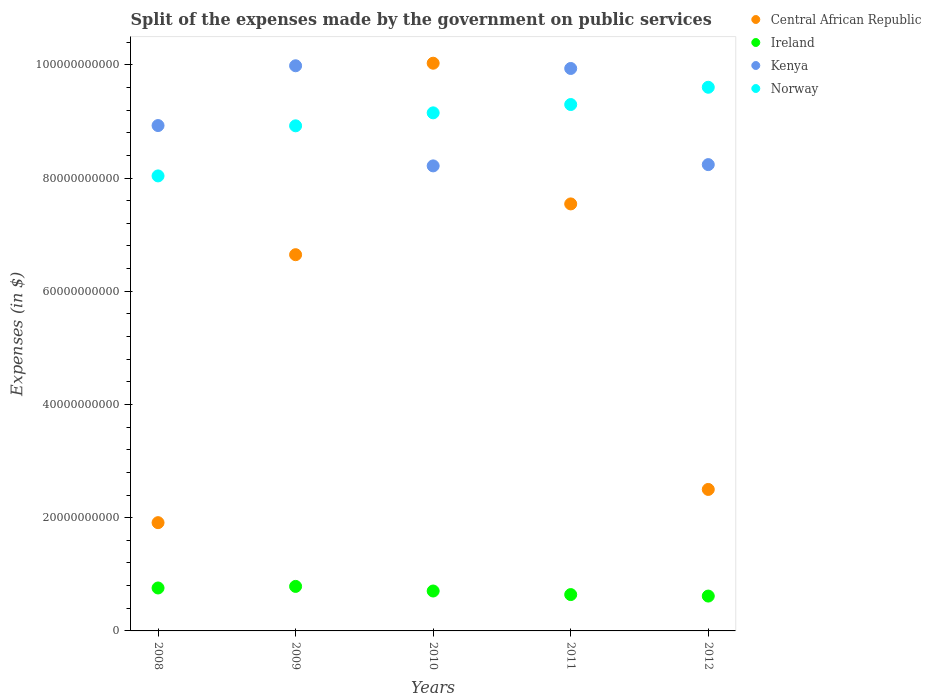How many different coloured dotlines are there?
Give a very brief answer. 4. What is the expenses made by the government on public services in Ireland in 2011?
Make the answer very short. 6.42e+09. Across all years, what is the maximum expenses made by the government on public services in Central African Republic?
Provide a short and direct response. 1.00e+11. Across all years, what is the minimum expenses made by the government on public services in Kenya?
Your response must be concise. 8.22e+1. In which year was the expenses made by the government on public services in Central African Republic maximum?
Provide a short and direct response. 2010. What is the total expenses made by the government on public services in Ireland in the graph?
Offer a terse response. 3.51e+1. What is the difference between the expenses made by the government on public services in Kenya in 2010 and that in 2011?
Provide a succinct answer. -1.72e+1. What is the difference between the expenses made by the government on public services in Norway in 2011 and the expenses made by the government on public services in Ireland in 2009?
Offer a very short reply. 8.51e+1. What is the average expenses made by the government on public services in Kenya per year?
Provide a short and direct response. 9.06e+1. In the year 2009, what is the difference between the expenses made by the government on public services in Ireland and expenses made by the government on public services in Kenya?
Ensure brevity in your answer.  -9.20e+1. What is the ratio of the expenses made by the government on public services in Norway in 2010 to that in 2012?
Offer a terse response. 0.95. Is the difference between the expenses made by the government on public services in Ireland in 2008 and 2011 greater than the difference between the expenses made by the government on public services in Kenya in 2008 and 2011?
Ensure brevity in your answer.  Yes. What is the difference between the highest and the second highest expenses made by the government on public services in Central African Republic?
Your answer should be compact. 2.49e+1. What is the difference between the highest and the lowest expenses made by the government on public services in Ireland?
Provide a short and direct response. 1.71e+09. Is the sum of the expenses made by the government on public services in Central African Republic in 2008 and 2009 greater than the maximum expenses made by the government on public services in Kenya across all years?
Offer a very short reply. No. Is it the case that in every year, the sum of the expenses made by the government on public services in Central African Republic and expenses made by the government on public services in Ireland  is greater than the sum of expenses made by the government on public services in Kenya and expenses made by the government on public services in Norway?
Offer a very short reply. No. Is it the case that in every year, the sum of the expenses made by the government on public services in Central African Republic and expenses made by the government on public services in Norway  is greater than the expenses made by the government on public services in Ireland?
Offer a very short reply. Yes. Is the expenses made by the government on public services in Central African Republic strictly greater than the expenses made by the government on public services in Ireland over the years?
Provide a short and direct response. Yes. Is the expenses made by the government on public services in Central African Republic strictly less than the expenses made by the government on public services in Kenya over the years?
Make the answer very short. No. How many dotlines are there?
Keep it short and to the point. 4. How many years are there in the graph?
Offer a terse response. 5. Are the values on the major ticks of Y-axis written in scientific E-notation?
Provide a short and direct response. No. Where does the legend appear in the graph?
Ensure brevity in your answer.  Top right. How many legend labels are there?
Give a very brief answer. 4. How are the legend labels stacked?
Offer a terse response. Vertical. What is the title of the graph?
Your response must be concise. Split of the expenses made by the government on public services. Does "Poland" appear as one of the legend labels in the graph?
Keep it short and to the point. No. What is the label or title of the Y-axis?
Make the answer very short. Expenses (in $). What is the Expenses (in $) of Central African Republic in 2008?
Offer a very short reply. 1.91e+1. What is the Expenses (in $) in Ireland in 2008?
Your answer should be compact. 7.59e+09. What is the Expenses (in $) of Kenya in 2008?
Provide a succinct answer. 8.93e+1. What is the Expenses (in $) in Norway in 2008?
Your answer should be compact. 8.04e+1. What is the Expenses (in $) of Central African Republic in 2009?
Offer a very short reply. 6.65e+1. What is the Expenses (in $) in Ireland in 2009?
Ensure brevity in your answer.  7.87e+09. What is the Expenses (in $) in Kenya in 2009?
Provide a succinct answer. 9.98e+1. What is the Expenses (in $) of Norway in 2009?
Make the answer very short. 8.92e+1. What is the Expenses (in $) of Central African Republic in 2010?
Your response must be concise. 1.00e+11. What is the Expenses (in $) of Ireland in 2010?
Your response must be concise. 7.05e+09. What is the Expenses (in $) in Kenya in 2010?
Provide a short and direct response. 8.22e+1. What is the Expenses (in $) in Norway in 2010?
Offer a terse response. 9.15e+1. What is the Expenses (in $) in Central African Republic in 2011?
Make the answer very short. 7.54e+1. What is the Expenses (in $) in Ireland in 2011?
Provide a short and direct response. 6.42e+09. What is the Expenses (in $) in Kenya in 2011?
Give a very brief answer. 9.94e+1. What is the Expenses (in $) of Norway in 2011?
Provide a succinct answer. 9.30e+1. What is the Expenses (in $) in Central African Republic in 2012?
Provide a succinct answer. 2.50e+1. What is the Expenses (in $) of Ireland in 2012?
Provide a short and direct response. 6.16e+09. What is the Expenses (in $) of Kenya in 2012?
Offer a very short reply. 8.24e+1. What is the Expenses (in $) in Norway in 2012?
Your response must be concise. 9.60e+1. Across all years, what is the maximum Expenses (in $) of Central African Republic?
Offer a very short reply. 1.00e+11. Across all years, what is the maximum Expenses (in $) of Ireland?
Your response must be concise. 7.87e+09. Across all years, what is the maximum Expenses (in $) in Kenya?
Give a very brief answer. 9.98e+1. Across all years, what is the maximum Expenses (in $) of Norway?
Ensure brevity in your answer.  9.60e+1. Across all years, what is the minimum Expenses (in $) of Central African Republic?
Give a very brief answer. 1.91e+1. Across all years, what is the minimum Expenses (in $) of Ireland?
Your answer should be very brief. 6.16e+09. Across all years, what is the minimum Expenses (in $) of Kenya?
Make the answer very short. 8.22e+1. Across all years, what is the minimum Expenses (in $) of Norway?
Ensure brevity in your answer.  8.04e+1. What is the total Expenses (in $) of Central African Republic in the graph?
Give a very brief answer. 2.86e+11. What is the total Expenses (in $) in Ireland in the graph?
Your response must be concise. 3.51e+1. What is the total Expenses (in $) in Kenya in the graph?
Your response must be concise. 4.53e+11. What is the total Expenses (in $) of Norway in the graph?
Offer a very short reply. 4.50e+11. What is the difference between the Expenses (in $) in Central African Republic in 2008 and that in 2009?
Provide a short and direct response. -4.73e+1. What is the difference between the Expenses (in $) of Ireland in 2008 and that in 2009?
Give a very brief answer. -2.79e+08. What is the difference between the Expenses (in $) of Kenya in 2008 and that in 2009?
Offer a terse response. -1.06e+1. What is the difference between the Expenses (in $) in Norway in 2008 and that in 2009?
Provide a succinct answer. -8.85e+09. What is the difference between the Expenses (in $) of Central African Republic in 2008 and that in 2010?
Provide a succinct answer. -8.12e+1. What is the difference between the Expenses (in $) in Ireland in 2008 and that in 2010?
Give a very brief answer. 5.35e+08. What is the difference between the Expenses (in $) in Kenya in 2008 and that in 2010?
Ensure brevity in your answer.  7.13e+09. What is the difference between the Expenses (in $) of Norway in 2008 and that in 2010?
Your answer should be very brief. -1.11e+1. What is the difference between the Expenses (in $) in Central African Republic in 2008 and that in 2011?
Make the answer very short. -5.63e+1. What is the difference between the Expenses (in $) in Ireland in 2008 and that in 2011?
Your response must be concise. 1.17e+09. What is the difference between the Expenses (in $) of Kenya in 2008 and that in 2011?
Your response must be concise. -1.01e+1. What is the difference between the Expenses (in $) of Norway in 2008 and that in 2011?
Give a very brief answer. -1.26e+1. What is the difference between the Expenses (in $) of Central African Republic in 2008 and that in 2012?
Your response must be concise. -5.87e+09. What is the difference between the Expenses (in $) of Ireland in 2008 and that in 2012?
Your answer should be compact. 1.43e+09. What is the difference between the Expenses (in $) of Kenya in 2008 and that in 2012?
Offer a very short reply. 6.90e+09. What is the difference between the Expenses (in $) in Norway in 2008 and that in 2012?
Offer a terse response. -1.57e+1. What is the difference between the Expenses (in $) of Central African Republic in 2009 and that in 2010?
Ensure brevity in your answer.  -3.38e+1. What is the difference between the Expenses (in $) of Ireland in 2009 and that in 2010?
Provide a short and direct response. 8.15e+08. What is the difference between the Expenses (in $) in Kenya in 2009 and that in 2010?
Ensure brevity in your answer.  1.77e+1. What is the difference between the Expenses (in $) of Norway in 2009 and that in 2010?
Provide a short and direct response. -2.29e+09. What is the difference between the Expenses (in $) of Central African Republic in 2009 and that in 2011?
Your answer should be very brief. -8.97e+09. What is the difference between the Expenses (in $) of Ireland in 2009 and that in 2011?
Provide a short and direct response. 1.45e+09. What is the difference between the Expenses (in $) of Kenya in 2009 and that in 2011?
Make the answer very short. 4.78e+08. What is the difference between the Expenses (in $) of Norway in 2009 and that in 2011?
Keep it short and to the point. -3.76e+09. What is the difference between the Expenses (in $) of Central African Republic in 2009 and that in 2012?
Your answer should be compact. 4.15e+1. What is the difference between the Expenses (in $) in Ireland in 2009 and that in 2012?
Offer a terse response. 1.71e+09. What is the difference between the Expenses (in $) in Kenya in 2009 and that in 2012?
Ensure brevity in your answer.  1.75e+1. What is the difference between the Expenses (in $) in Norway in 2009 and that in 2012?
Your response must be concise. -6.81e+09. What is the difference between the Expenses (in $) in Central African Republic in 2010 and that in 2011?
Make the answer very short. 2.49e+1. What is the difference between the Expenses (in $) of Ireland in 2010 and that in 2011?
Keep it short and to the point. 6.31e+08. What is the difference between the Expenses (in $) in Kenya in 2010 and that in 2011?
Keep it short and to the point. -1.72e+1. What is the difference between the Expenses (in $) of Norway in 2010 and that in 2011?
Ensure brevity in your answer.  -1.47e+09. What is the difference between the Expenses (in $) of Central African Republic in 2010 and that in 2012?
Provide a short and direct response. 7.53e+1. What is the difference between the Expenses (in $) in Ireland in 2010 and that in 2012?
Make the answer very short. 8.94e+08. What is the difference between the Expenses (in $) of Kenya in 2010 and that in 2012?
Offer a very short reply. -2.26e+08. What is the difference between the Expenses (in $) in Norway in 2010 and that in 2012?
Keep it short and to the point. -4.52e+09. What is the difference between the Expenses (in $) of Central African Republic in 2011 and that in 2012?
Your response must be concise. 5.04e+1. What is the difference between the Expenses (in $) of Ireland in 2011 and that in 2012?
Provide a succinct answer. 2.63e+08. What is the difference between the Expenses (in $) of Kenya in 2011 and that in 2012?
Your response must be concise. 1.70e+1. What is the difference between the Expenses (in $) in Norway in 2011 and that in 2012?
Give a very brief answer. -3.05e+09. What is the difference between the Expenses (in $) of Central African Republic in 2008 and the Expenses (in $) of Ireland in 2009?
Make the answer very short. 1.13e+1. What is the difference between the Expenses (in $) of Central African Republic in 2008 and the Expenses (in $) of Kenya in 2009?
Ensure brevity in your answer.  -8.07e+1. What is the difference between the Expenses (in $) of Central African Republic in 2008 and the Expenses (in $) of Norway in 2009?
Your answer should be very brief. -7.01e+1. What is the difference between the Expenses (in $) of Ireland in 2008 and the Expenses (in $) of Kenya in 2009?
Your answer should be compact. -9.23e+1. What is the difference between the Expenses (in $) in Ireland in 2008 and the Expenses (in $) in Norway in 2009?
Your answer should be very brief. -8.16e+1. What is the difference between the Expenses (in $) of Kenya in 2008 and the Expenses (in $) of Norway in 2009?
Offer a very short reply. 4.59e+07. What is the difference between the Expenses (in $) in Central African Republic in 2008 and the Expenses (in $) in Ireland in 2010?
Your answer should be very brief. 1.21e+1. What is the difference between the Expenses (in $) of Central African Republic in 2008 and the Expenses (in $) of Kenya in 2010?
Provide a succinct answer. -6.30e+1. What is the difference between the Expenses (in $) of Central African Republic in 2008 and the Expenses (in $) of Norway in 2010?
Offer a very short reply. -7.24e+1. What is the difference between the Expenses (in $) in Ireland in 2008 and the Expenses (in $) in Kenya in 2010?
Provide a short and direct response. -7.46e+1. What is the difference between the Expenses (in $) in Ireland in 2008 and the Expenses (in $) in Norway in 2010?
Provide a short and direct response. -8.39e+1. What is the difference between the Expenses (in $) of Kenya in 2008 and the Expenses (in $) of Norway in 2010?
Offer a very short reply. -2.24e+09. What is the difference between the Expenses (in $) of Central African Republic in 2008 and the Expenses (in $) of Ireland in 2011?
Make the answer very short. 1.27e+1. What is the difference between the Expenses (in $) in Central African Republic in 2008 and the Expenses (in $) in Kenya in 2011?
Your answer should be very brief. -8.02e+1. What is the difference between the Expenses (in $) of Central African Republic in 2008 and the Expenses (in $) of Norway in 2011?
Offer a terse response. -7.39e+1. What is the difference between the Expenses (in $) in Ireland in 2008 and the Expenses (in $) in Kenya in 2011?
Make the answer very short. -9.18e+1. What is the difference between the Expenses (in $) of Ireland in 2008 and the Expenses (in $) of Norway in 2011?
Ensure brevity in your answer.  -8.54e+1. What is the difference between the Expenses (in $) of Kenya in 2008 and the Expenses (in $) of Norway in 2011?
Give a very brief answer. -3.71e+09. What is the difference between the Expenses (in $) in Central African Republic in 2008 and the Expenses (in $) in Ireland in 2012?
Give a very brief answer. 1.30e+1. What is the difference between the Expenses (in $) in Central African Republic in 2008 and the Expenses (in $) in Kenya in 2012?
Offer a terse response. -6.33e+1. What is the difference between the Expenses (in $) in Central African Republic in 2008 and the Expenses (in $) in Norway in 2012?
Offer a very short reply. -7.69e+1. What is the difference between the Expenses (in $) in Ireland in 2008 and the Expenses (in $) in Kenya in 2012?
Ensure brevity in your answer.  -7.48e+1. What is the difference between the Expenses (in $) in Ireland in 2008 and the Expenses (in $) in Norway in 2012?
Give a very brief answer. -8.85e+1. What is the difference between the Expenses (in $) in Kenya in 2008 and the Expenses (in $) in Norway in 2012?
Provide a short and direct response. -6.76e+09. What is the difference between the Expenses (in $) of Central African Republic in 2009 and the Expenses (in $) of Ireland in 2010?
Offer a very short reply. 5.94e+1. What is the difference between the Expenses (in $) of Central African Republic in 2009 and the Expenses (in $) of Kenya in 2010?
Give a very brief answer. -1.57e+1. What is the difference between the Expenses (in $) of Central African Republic in 2009 and the Expenses (in $) of Norway in 2010?
Keep it short and to the point. -2.51e+1. What is the difference between the Expenses (in $) of Ireland in 2009 and the Expenses (in $) of Kenya in 2010?
Offer a terse response. -7.43e+1. What is the difference between the Expenses (in $) in Ireland in 2009 and the Expenses (in $) in Norway in 2010?
Your answer should be very brief. -8.37e+1. What is the difference between the Expenses (in $) of Kenya in 2009 and the Expenses (in $) of Norway in 2010?
Keep it short and to the point. 8.32e+09. What is the difference between the Expenses (in $) of Central African Republic in 2009 and the Expenses (in $) of Ireland in 2011?
Give a very brief answer. 6.00e+1. What is the difference between the Expenses (in $) of Central African Republic in 2009 and the Expenses (in $) of Kenya in 2011?
Make the answer very short. -3.29e+1. What is the difference between the Expenses (in $) in Central African Republic in 2009 and the Expenses (in $) in Norway in 2011?
Give a very brief answer. -2.65e+1. What is the difference between the Expenses (in $) in Ireland in 2009 and the Expenses (in $) in Kenya in 2011?
Keep it short and to the point. -9.15e+1. What is the difference between the Expenses (in $) of Ireland in 2009 and the Expenses (in $) of Norway in 2011?
Offer a terse response. -8.51e+1. What is the difference between the Expenses (in $) in Kenya in 2009 and the Expenses (in $) in Norway in 2011?
Make the answer very short. 6.85e+09. What is the difference between the Expenses (in $) of Central African Republic in 2009 and the Expenses (in $) of Ireland in 2012?
Your response must be concise. 6.03e+1. What is the difference between the Expenses (in $) in Central African Republic in 2009 and the Expenses (in $) in Kenya in 2012?
Provide a succinct answer. -1.59e+1. What is the difference between the Expenses (in $) in Central African Republic in 2009 and the Expenses (in $) in Norway in 2012?
Keep it short and to the point. -2.96e+1. What is the difference between the Expenses (in $) in Ireland in 2009 and the Expenses (in $) in Kenya in 2012?
Offer a terse response. -7.45e+1. What is the difference between the Expenses (in $) in Ireland in 2009 and the Expenses (in $) in Norway in 2012?
Your answer should be compact. -8.82e+1. What is the difference between the Expenses (in $) in Kenya in 2009 and the Expenses (in $) in Norway in 2012?
Keep it short and to the point. 3.80e+09. What is the difference between the Expenses (in $) in Central African Republic in 2010 and the Expenses (in $) in Ireland in 2011?
Make the answer very short. 9.39e+1. What is the difference between the Expenses (in $) of Central African Republic in 2010 and the Expenses (in $) of Kenya in 2011?
Your answer should be compact. 9.28e+08. What is the difference between the Expenses (in $) of Central African Republic in 2010 and the Expenses (in $) of Norway in 2011?
Ensure brevity in your answer.  7.30e+09. What is the difference between the Expenses (in $) in Ireland in 2010 and the Expenses (in $) in Kenya in 2011?
Provide a succinct answer. -9.23e+1. What is the difference between the Expenses (in $) in Ireland in 2010 and the Expenses (in $) in Norway in 2011?
Your answer should be compact. -8.59e+1. What is the difference between the Expenses (in $) in Kenya in 2010 and the Expenses (in $) in Norway in 2011?
Your answer should be compact. -1.08e+1. What is the difference between the Expenses (in $) of Central African Republic in 2010 and the Expenses (in $) of Ireland in 2012?
Offer a terse response. 9.41e+1. What is the difference between the Expenses (in $) of Central African Republic in 2010 and the Expenses (in $) of Kenya in 2012?
Ensure brevity in your answer.  1.79e+1. What is the difference between the Expenses (in $) in Central African Republic in 2010 and the Expenses (in $) in Norway in 2012?
Provide a short and direct response. 4.25e+09. What is the difference between the Expenses (in $) in Ireland in 2010 and the Expenses (in $) in Kenya in 2012?
Offer a very short reply. -7.53e+1. What is the difference between the Expenses (in $) of Ireland in 2010 and the Expenses (in $) of Norway in 2012?
Offer a terse response. -8.90e+1. What is the difference between the Expenses (in $) in Kenya in 2010 and the Expenses (in $) in Norway in 2012?
Offer a terse response. -1.39e+1. What is the difference between the Expenses (in $) in Central African Republic in 2011 and the Expenses (in $) in Ireland in 2012?
Your answer should be very brief. 6.93e+1. What is the difference between the Expenses (in $) of Central African Republic in 2011 and the Expenses (in $) of Kenya in 2012?
Your response must be concise. -6.94e+09. What is the difference between the Expenses (in $) in Central African Republic in 2011 and the Expenses (in $) in Norway in 2012?
Give a very brief answer. -2.06e+1. What is the difference between the Expenses (in $) of Ireland in 2011 and the Expenses (in $) of Kenya in 2012?
Offer a terse response. -7.60e+1. What is the difference between the Expenses (in $) of Ireland in 2011 and the Expenses (in $) of Norway in 2012?
Offer a very short reply. -8.96e+1. What is the difference between the Expenses (in $) in Kenya in 2011 and the Expenses (in $) in Norway in 2012?
Ensure brevity in your answer.  3.32e+09. What is the average Expenses (in $) of Central African Republic per year?
Your response must be concise. 5.73e+1. What is the average Expenses (in $) of Ireland per year?
Offer a very short reply. 7.02e+09. What is the average Expenses (in $) in Kenya per year?
Offer a very short reply. 9.06e+1. What is the average Expenses (in $) in Norway per year?
Your answer should be compact. 9.00e+1. In the year 2008, what is the difference between the Expenses (in $) in Central African Republic and Expenses (in $) in Ireland?
Keep it short and to the point. 1.15e+1. In the year 2008, what is the difference between the Expenses (in $) of Central African Republic and Expenses (in $) of Kenya?
Provide a succinct answer. -7.02e+1. In the year 2008, what is the difference between the Expenses (in $) of Central African Republic and Expenses (in $) of Norway?
Ensure brevity in your answer.  -6.13e+1. In the year 2008, what is the difference between the Expenses (in $) of Ireland and Expenses (in $) of Kenya?
Your answer should be compact. -8.17e+1. In the year 2008, what is the difference between the Expenses (in $) in Ireland and Expenses (in $) in Norway?
Offer a very short reply. -7.28e+1. In the year 2008, what is the difference between the Expenses (in $) of Kenya and Expenses (in $) of Norway?
Offer a very short reply. 8.90e+09. In the year 2009, what is the difference between the Expenses (in $) of Central African Republic and Expenses (in $) of Ireland?
Your response must be concise. 5.86e+1. In the year 2009, what is the difference between the Expenses (in $) in Central African Republic and Expenses (in $) in Kenya?
Offer a very short reply. -3.34e+1. In the year 2009, what is the difference between the Expenses (in $) in Central African Republic and Expenses (in $) in Norway?
Keep it short and to the point. -2.28e+1. In the year 2009, what is the difference between the Expenses (in $) in Ireland and Expenses (in $) in Kenya?
Provide a succinct answer. -9.20e+1. In the year 2009, what is the difference between the Expenses (in $) of Ireland and Expenses (in $) of Norway?
Make the answer very short. -8.14e+1. In the year 2009, what is the difference between the Expenses (in $) of Kenya and Expenses (in $) of Norway?
Your answer should be very brief. 1.06e+1. In the year 2010, what is the difference between the Expenses (in $) in Central African Republic and Expenses (in $) in Ireland?
Provide a short and direct response. 9.32e+1. In the year 2010, what is the difference between the Expenses (in $) in Central African Republic and Expenses (in $) in Kenya?
Make the answer very short. 1.81e+1. In the year 2010, what is the difference between the Expenses (in $) in Central African Republic and Expenses (in $) in Norway?
Your answer should be compact. 8.77e+09. In the year 2010, what is the difference between the Expenses (in $) of Ireland and Expenses (in $) of Kenya?
Ensure brevity in your answer.  -7.51e+1. In the year 2010, what is the difference between the Expenses (in $) in Ireland and Expenses (in $) in Norway?
Make the answer very short. -8.45e+1. In the year 2010, what is the difference between the Expenses (in $) of Kenya and Expenses (in $) of Norway?
Ensure brevity in your answer.  -9.37e+09. In the year 2011, what is the difference between the Expenses (in $) in Central African Republic and Expenses (in $) in Ireland?
Make the answer very short. 6.90e+1. In the year 2011, what is the difference between the Expenses (in $) of Central African Republic and Expenses (in $) of Kenya?
Make the answer very short. -2.39e+1. In the year 2011, what is the difference between the Expenses (in $) in Central African Republic and Expenses (in $) in Norway?
Your answer should be compact. -1.76e+1. In the year 2011, what is the difference between the Expenses (in $) in Ireland and Expenses (in $) in Kenya?
Provide a short and direct response. -9.29e+1. In the year 2011, what is the difference between the Expenses (in $) of Ireland and Expenses (in $) of Norway?
Give a very brief answer. -8.66e+1. In the year 2011, what is the difference between the Expenses (in $) in Kenya and Expenses (in $) in Norway?
Keep it short and to the point. 6.37e+09. In the year 2012, what is the difference between the Expenses (in $) of Central African Republic and Expenses (in $) of Ireland?
Give a very brief answer. 1.88e+1. In the year 2012, what is the difference between the Expenses (in $) in Central African Republic and Expenses (in $) in Kenya?
Ensure brevity in your answer.  -5.74e+1. In the year 2012, what is the difference between the Expenses (in $) in Central African Republic and Expenses (in $) in Norway?
Your response must be concise. -7.10e+1. In the year 2012, what is the difference between the Expenses (in $) in Ireland and Expenses (in $) in Kenya?
Keep it short and to the point. -7.62e+1. In the year 2012, what is the difference between the Expenses (in $) in Ireland and Expenses (in $) in Norway?
Offer a terse response. -8.99e+1. In the year 2012, what is the difference between the Expenses (in $) in Kenya and Expenses (in $) in Norway?
Keep it short and to the point. -1.37e+1. What is the ratio of the Expenses (in $) of Central African Republic in 2008 to that in 2009?
Give a very brief answer. 0.29. What is the ratio of the Expenses (in $) in Ireland in 2008 to that in 2009?
Keep it short and to the point. 0.96. What is the ratio of the Expenses (in $) of Kenya in 2008 to that in 2009?
Offer a terse response. 0.89. What is the ratio of the Expenses (in $) in Norway in 2008 to that in 2009?
Give a very brief answer. 0.9. What is the ratio of the Expenses (in $) in Central African Republic in 2008 to that in 2010?
Your response must be concise. 0.19. What is the ratio of the Expenses (in $) in Ireland in 2008 to that in 2010?
Your response must be concise. 1.08. What is the ratio of the Expenses (in $) of Kenya in 2008 to that in 2010?
Make the answer very short. 1.09. What is the ratio of the Expenses (in $) of Norway in 2008 to that in 2010?
Provide a succinct answer. 0.88. What is the ratio of the Expenses (in $) in Central African Republic in 2008 to that in 2011?
Offer a very short reply. 0.25. What is the ratio of the Expenses (in $) in Ireland in 2008 to that in 2011?
Provide a short and direct response. 1.18. What is the ratio of the Expenses (in $) of Kenya in 2008 to that in 2011?
Your answer should be compact. 0.9. What is the ratio of the Expenses (in $) of Norway in 2008 to that in 2011?
Offer a terse response. 0.86. What is the ratio of the Expenses (in $) of Central African Republic in 2008 to that in 2012?
Offer a terse response. 0.77. What is the ratio of the Expenses (in $) in Ireland in 2008 to that in 2012?
Your answer should be compact. 1.23. What is the ratio of the Expenses (in $) in Kenya in 2008 to that in 2012?
Offer a terse response. 1.08. What is the ratio of the Expenses (in $) of Norway in 2008 to that in 2012?
Offer a terse response. 0.84. What is the ratio of the Expenses (in $) in Central African Republic in 2009 to that in 2010?
Keep it short and to the point. 0.66. What is the ratio of the Expenses (in $) in Ireland in 2009 to that in 2010?
Provide a short and direct response. 1.12. What is the ratio of the Expenses (in $) in Kenya in 2009 to that in 2010?
Offer a terse response. 1.22. What is the ratio of the Expenses (in $) of Norway in 2009 to that in 2010?
Offer a very short reply. 0.97. What is the ratio of the Expenses (in $) in Central African Republic in 2009 to that in 2011?
Offer a terse response. 0.88. What is the ratio of the Expenses (in $) of Ireland in 2009 to that in 2011?
Provide a short and direct response. 1.23. What is the ratio of the Expenses (in $) in Kenya in 2009 to that in 2011?
Provide a succinct answer. 1. What is the ratio of the Expenses (in $) in Norway in 2009 to that in 2011?
Make the answer very short. 0.96. What is the ratio of the Expenses (in $) in Central African Republic in 2009 to that in 2012?
Give a very brief answer. 2.66. What is the ratio of the Expenses (in $) in Ireland in 2009 to that in 2012?
Your response must be concise. 1.28. What is the ratio of the Expenses (in $) of Kenya in 2009 to that in 2012?
Offer a terse response. 1.21. What is the ratio of the Expenses (in $) in Norway in 2009 to that in 2012?
Make the answer very short. 0.93. What is the ratio of the Expenses (in $) of Central African Republic in 2010 to that in 2011?
Make the answer very short. 1.33. What is the ratio of the Expenses (in $) in Ireland in 2010 to that in 2011?
Give a very brief answer. 1.1. What is the ratio of the Expenses (in $) in Kenya in 2010 to that in 2011?
Keep it short and to the point. 0.83. What is the ratio of the Expenses (in $) of Norway in 2010 to that in 2011?
Ensure brevity in your answer.  0.98. What is the ratio of the Expenses (in $) in Central African Republic in 2010 to that in 2012?
Provide a short and direct response. 4.01. What is the ratio of the Expenses (in $) in Ireland in 2010 to that in 2012?
Make the answer very short. 1.15. What is the ratio of the Expenses (in $) of Norway in 2010 to that in 2012?
Your response must be concise. 0.95. What is the ratio of the Expenses (in $) of Central African Republic in 2011 to that in 2012?
Your response must be concise. 3.02. What is the ratio of the Expenses (in $) in Ireland in 2011 to that in 2012?
Provide a succinct answer. 1.04. What is the ratio of the Expenses (in $) of Kenya in 2011 to that in 2012?
Offer a terse response. 1.21. What is the ratio of the Expenses (in $) of Norway in 2011 to that in 2012?
Keep it short and to the point. 0.97. What is the difference between the highest and the second highest Expenses (in $) of Central African Republic?
Make the answer very short. 2.49e+1. What is the difference between the highest and the second highest Expenses (in $) of Ireland?
Make the answer very short. 2.79e+08. What is the difference between the highest and the second highest Expenses (in $) of Kenya?
Ensure brevity in your answer.  4.78e+08. What is the difference between the highest and the second highest Expenses (in $) of Norway?
Provide a succinct answer. 3.05e+09. What is the difference between the highest and the lowest Expenses (in $) of Central African Republic?
Offer a very short reply. 8.12e+1. What is the difference between the highest and the lowest Expenses (in $) of Ireland?
Keep it short and to the point. 1.71e+09. What is the difference between the highest and the lowest Expenses (in $) of Kenya?
Your answer should be very brief. 1.77e+1. What is the difference between the highest and the lowest Expenses (in $) of Norway?
Make the answer very short. 1.57e+1. 